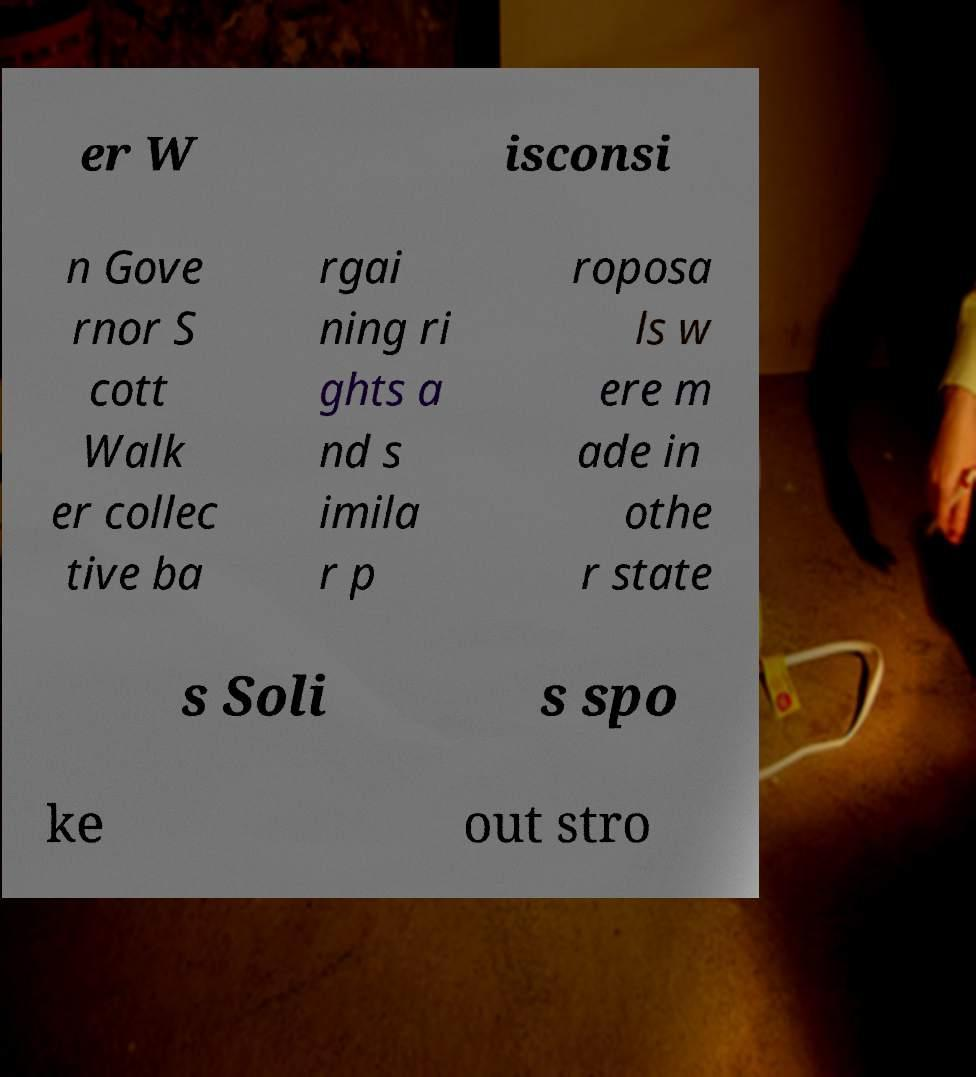For documentation purposes, I need the text within this image transcribed. Could you provide that? er W isconsi n Gove rnor S cott Walk er collec tive ba rgai ning ri ghts a nd s imila r p roposa ls w ere m ade in othe r state s Soli s spo ke out stro 